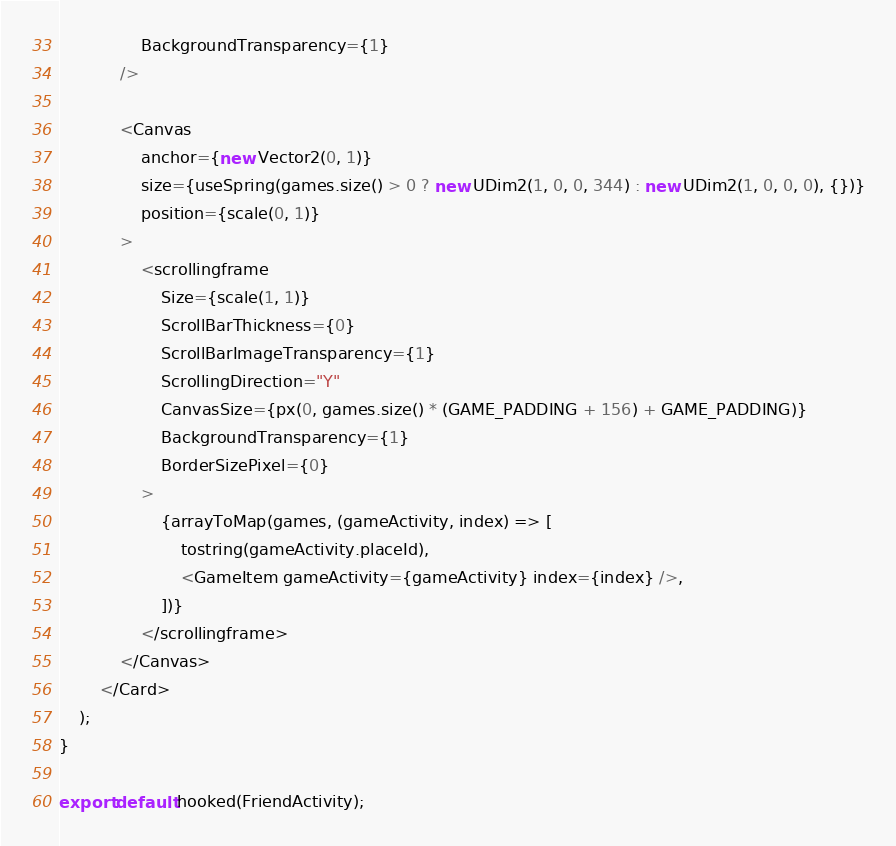<code> <loc_0><loc_0><loc_500><loc_500><_TypeScript_>				BackgroundTransparency={1}
			/>

			<Canvas
				anchor={new Vector2(0, 1)}
				size={useSpring(games.size() > 0 ? new UDim2(1, 0, 0, 344) : new UDim2(1, 0, 0, 0), {})}
				position={scale(0, 1)}
			>
				<scrollingframe
					Size={scale(1, 1)}
					ScrollBarThickness={0}
					ScrollBarImageTransparency={1}
					ScrollingDirection="Y"
					CanvasSize={px(0, games.size() * (GAME_PADDING + 156) + GAME_PADDING)}
					BackgroundTransparency={1}
					BorderSizePixel={0}
				>
					{arrayToMap(games, (gameActivity, index) => [
						tostring(gameActivity.placeId),
						<GameItem gameActivity={gameActivity} index={index} />,
					])}
				</scrollingframe>
			</Canvas>
		</Card>
	);
}

export default hooked(FriendActivity);
</code> 